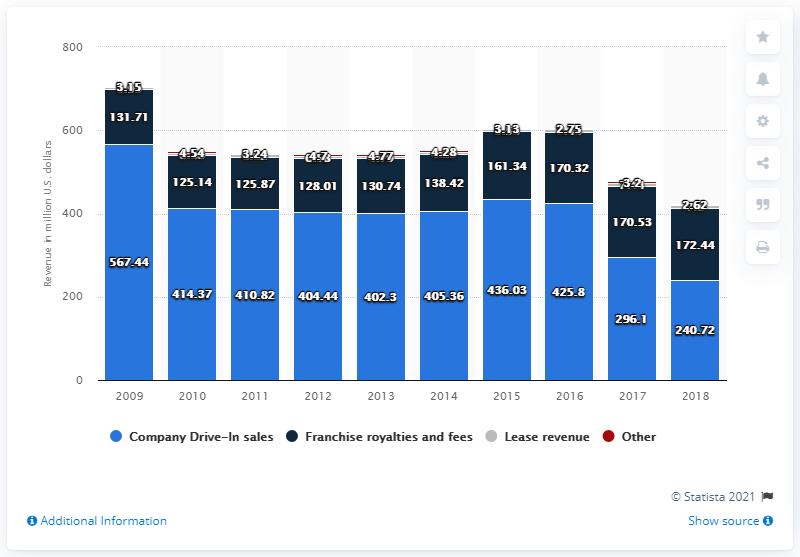Highlight a few significant elements in this photo. Sonic Corporation's revenue in 2018 was 240.72 million. 